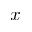Convert formula to latex. <formula><loc_0><loc_0><loc_500><loc_500>x</formula> 